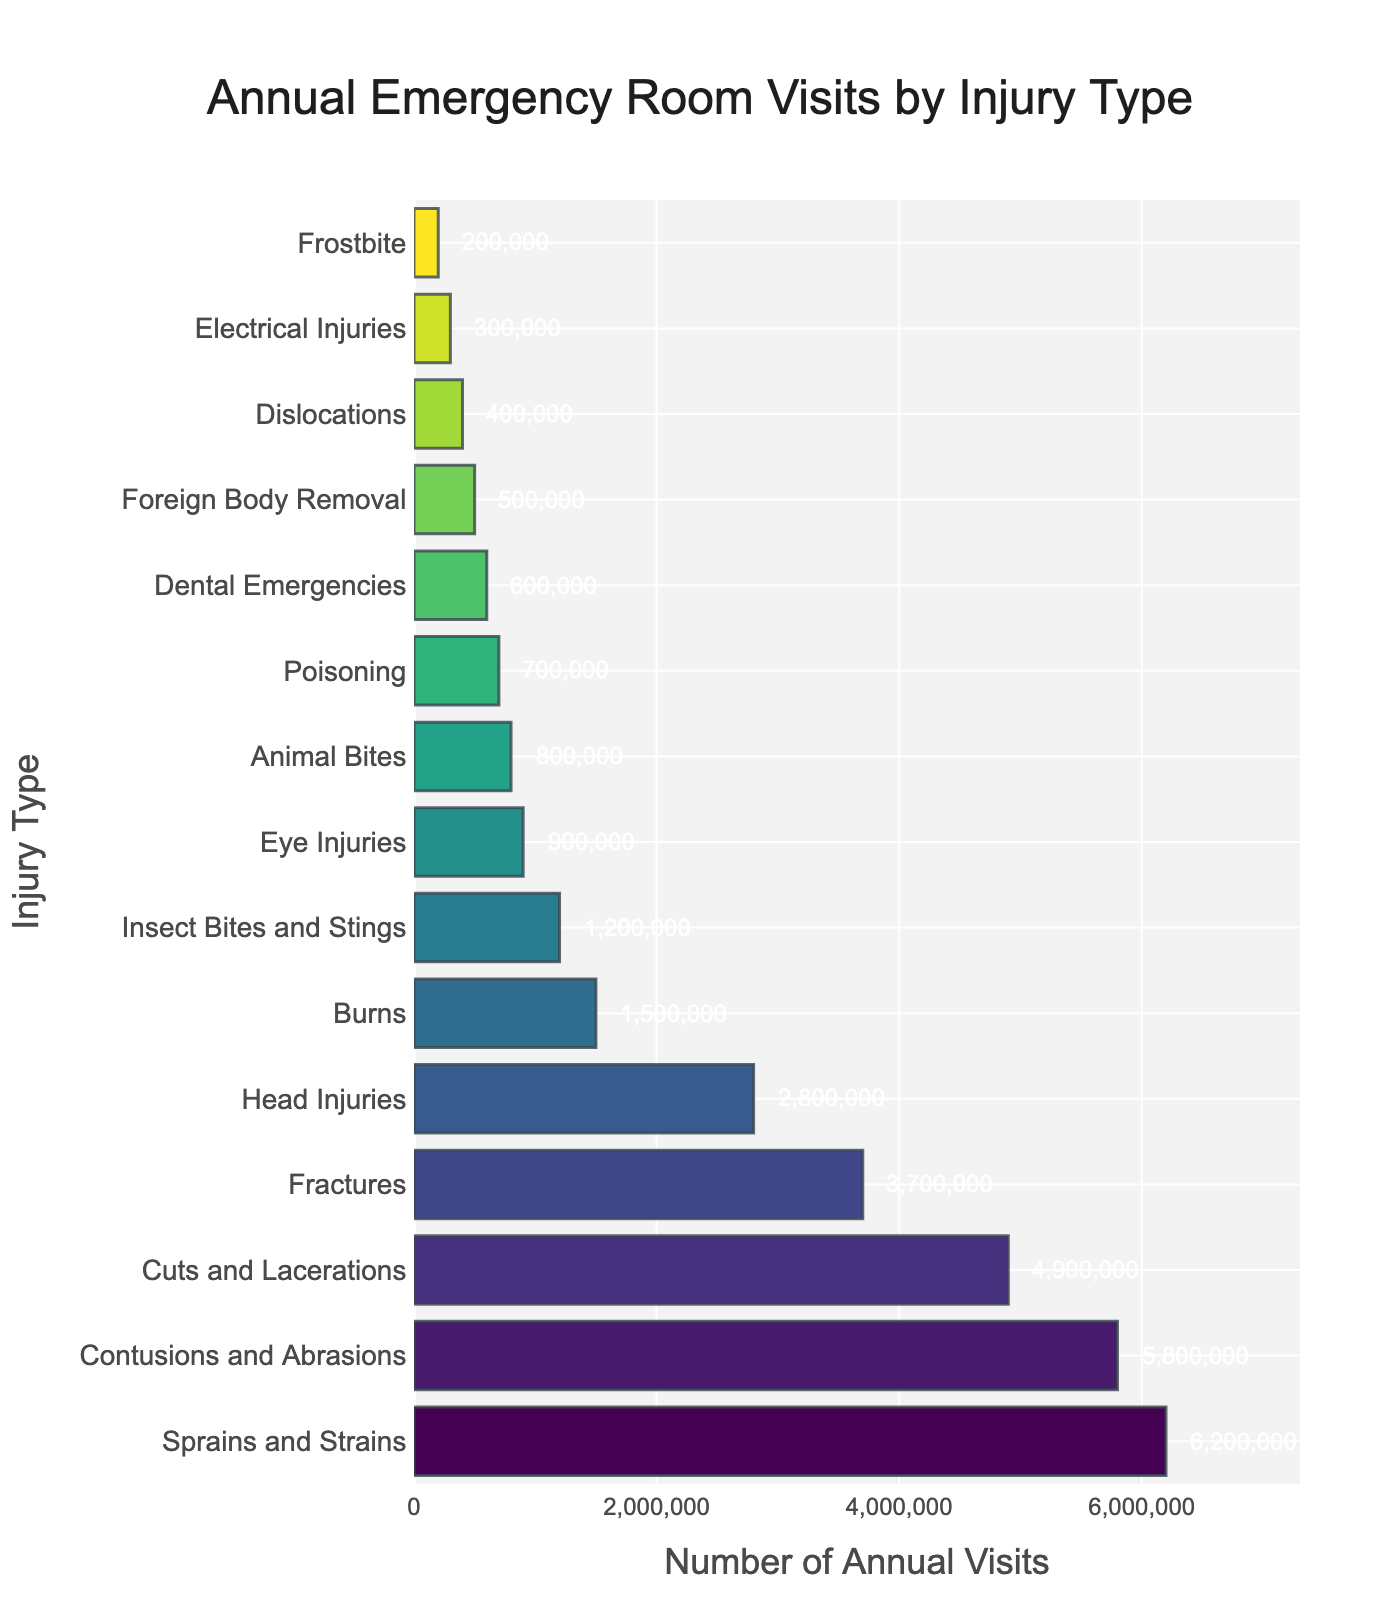What is the most common injury type in terms of annual visits? The figure shows the number of annual visits for various injury types. The highest bar represents the most common injury type. Sprains and Strains have the highest bar with 6,200,000 annual visits.
Answer: Sprains and Strains Which injury type has fewer annual visits: Fractures or Head Injuries? By comparing the heights of the bars for Fractures and Head Injuries, Fractures have lengths corresponding to 3,700,000 visits, and Head Injuries correspond to 2,800,000 visits. Therefore, Head Injuries have fewer annual visits.
Answer: Head Injuries What is the combined total of annual visits for Cuts and Lacerations and Burns? To find the combined total, look at the individual bars for Cuts and Lacerations (4,900,000 visits) and Burns (1,500,000 visits). Sum them up: 4,900,000 + 1,500,000 = 6,400,000.
Answer: 6,400,000 Calculate the difference in annual visits between Contusions and Abrasions and Eye Injuries. Subtract the number of visits for Eye Injuries (900,000) from the visits for Contusions and Abrasions (5,800,000). The difference is 5,800,000 - 900,000 = 4,900,000.
Answer: 4,900,000 Which types of injuries have an annual visit frequency greater than 3,000,000? To answer this, identify all bars with lengths greater than 3,000,000. These are Sprains and Strains (6,200,000), Contusions and Abrasions (5,800,000), Cuts and Lacerations (4,900,000), and Fractures (3,700,000).
Answer: Sprains and Strains, Contusions and Abrasions, Cuts and Lacerations, Fractures How many injury types have annual visits less than 1,000,000? Count the bars with lengths less than 1,000,000. These are Eye Injuries (900,000), Animal Bites (800,000), Poisoning (700,000), Dental Emergencies (600,000), Foreign Body Removal (500,000), Dislocations (400,000), Electrical Injuries (300,000), and Frostbite (200,000). There are 8 in total.
Answer: 8 What percentage of the total annual visits are due to Sprains and Strains? First, calculate the total number of annual visits by summing all bars. The total is 26,100,000 visits. Then, divide the number of visits for Sprains and Strains (6,200,000) by the total and multiply by 100: (6,200,000 / 26,100,000) * 100 ≈ 23.75%.
Answer: 23.75% Are Fractures more common than Burns? Compare the lengths of the bars corresponding to Fractures (3,700,000 visits) and Burns (1,500,000 visits). Since 3,700,000 is greater than 1,500,000, Fractures are more common.
Answer: Yes Which injury type is represented by the shortest bar in the chart? The shortest bar corresponds to the lowest number of annual visits, which is Frostbite with 200,000 annual visits.
Answer: Frostbite 